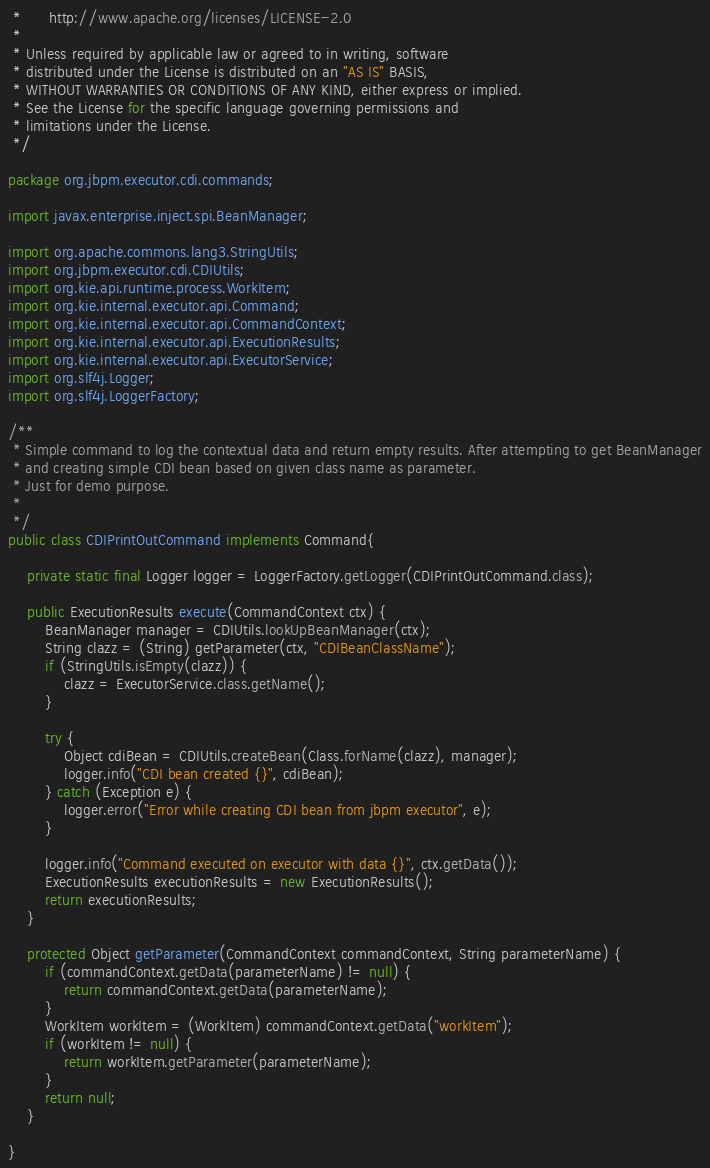<code> <loc_0><loc_0><loc_500><loc_500><_Java_> *      http://www.apache.org/licenses/LICENSE-2.0
 *
 * Unless required by applicable law or agreed to in writing, software
 * distributed under the License is distributed on an "AS IS" BASIS,
 * WITHOUT WARRANTIES OR CONDITIONS OF ANY KIND, either express or implied.
 * See the License for the specific language governing permissions and
 * limitations under the License.
 */

package org.jbpm.executor.cdi.commands;

import javax.enterprise.inject.spi.BeanManager;

import org.apache.commons.lang3.StringUtils;
import org.jbpm.executor.cdi.CDIUtils;
import org.kie.api.runtime.process.WorkItem;
import org.kie.internal.executor.api.Command;
import org.kie.internal.executor.api.CommandContext;
import org.kie.internal.executor.api.ExecutionResults;
import org.kie.internal.executor.api.ExecutorService;
import org.slf4j.Logger;
import org.slf4j.LoggerFactory;

/**
 * Simple command to log the contextual data and return empty results. After attempting to get BeanManager
 * and creating simple CDI bean based on given class name as parameter. 
 * Just for demo purpose.
 * 
 */
public class CDIPrintOutCommand implements Command{
    
    private static final Logger logger = LoggerFactory.getLogger(CDIPrintOutCommand.class);

    public ExecutionResults execute(CommandContext ctx) {
    	BeanManager manager = CDIUtils.lookUpBeanManager(ctx);
    	String clazz = (String) getParameter(ctx, "CDIBeanClassName");
    	if (StringUtils.isEmpty(clazz)) {
    		clazz = ExecutorService.class.getName();
    	}
    			
    	try {
			Object cdiBean = CDIUtils.createBean(Class.forName(clazz), manager);
			logger.info("CDI bean created {}", cdiBean);
		} catch (Exception e) {		
			logger.error("Error while creating CDI bean from jbpm executor", e);
		}
    	
        logger.info("Command executed on executor with data {}", ctx.getData());
        ExecutionResults executionResults = new ExecutionResults();
        return executionResults;
    }
    
    protected Object getParameter(CommandContext commandContext, String parameterName) {
		if (commandContext.getData(parameterName) != null) {
			return commandContext.getData(parameterName);
		}
		WorkItem workItem = (WorkItem) commandContext.getData("workItem");
		if (workItem != null) {
			return workItem.getParameter(parameterName);
		}
		return null;
	}
    
}
</code> 